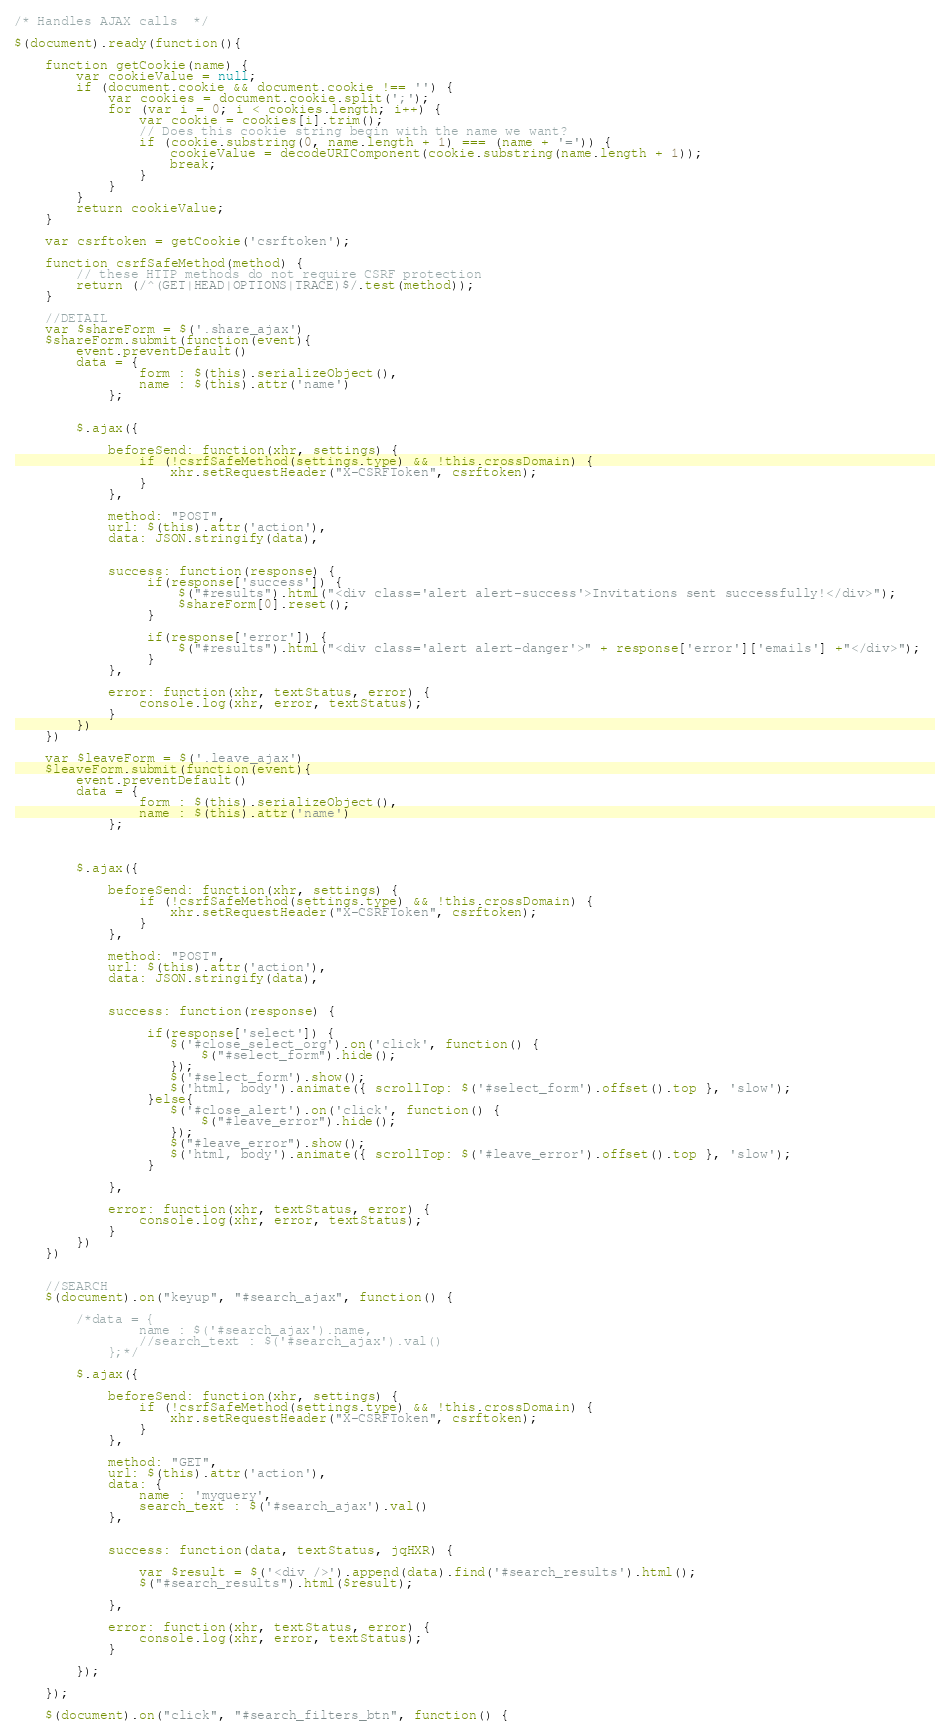<code> <loc_0><loc_0><loc_500><loc_500><_JavaScript_>/* Handles AJAX calls  */

$(document).ready(function(){

    function getCookie(name) {
        var cookieValue = null;
        if (document.cookie && document.cookie !== '') {
            var cookies = document.cookie.split(';');
            for (var i = 0; i < cookies.length; i++) {
                var cookie = cookies[i].trim();
                // Does this cookie string begin with the name we want?
                if (cookie.substring(0, name.length + 1) === (name + '=')) {
                    cookieValue = decodeURIComponent(cookie.substring(name.length + 1));
                    break;
                }
            }
        }
        return cookieValue;
    }

    var csrftoken = getCookie('csrftoken');

    function csrfSafeMethod(method) {
        // these HTTP methods do not require CSRF protection
        return (/^(GET|HEAD|OPTIONS|TRACE)$/.test(method));
    }

    //DETAIL
    var $shareForm = $('.share_ajax')
    $shareForm.submit(function(event){
        event.preventDefault()
        data = {
                form : $(this).serializeObject(),
                name : $(this).attr('name')
            };


        $.ajax({

            beforeSend: function(xhr, settings) {
                if (!csrfSafeMethod(settings.type) && !this.crossDomain) {
                    xhr.setRequestHeader("X-CSRFToken", csrftoken);
                }
            },

            method: "POST",
            url: $(this).attr('action'),
            data: JSON.stringify(data),


            success: function(response) {
                 if(response['success']) {
                     $("#results").html("<div class='alert alert-success'>Invitations sent successfully!</div>");
                     $shareForm[0].reset();
                 }

                 if(response['error']) {
                     $("#results").html("<div class='alert alert-danger'>" + response['error']['emails'] +"</div>");
                 }
            },

            error: function(xhr, textStatus, error) {
                console.log(xhr, error, textStatus);
            }
        })
    })

    var $leaveForm = $('.leave_ajax')
    $leaveForm.submit(function(event){
        event.preventDefault()
        data = {
                form : $(this).serializeObject(),
                name : $(this).attr('name')
            };

        

        $.ajax({

            beforeSend: function(xhr, settings) {
                if (!csrfSafeMethod(settings.type) && !this.crossDomain) {
                    xhr.setRequestHeader("X-CSRFToken", csrftoken);
                }
            },

            method: "POST",
            url: $(this).attr('action'),
            data: JSON.stringify(data),


            success: function(response) {

                 if(response['select']) {
                    $('#close_select_org').on('click', function() {
                        $("#select_form").hide();  
                    });
                    $('#select_form').show();
                    $('html, body').animate({ scrollTop: $('#select_form').offset().top }, 'slow');
                 }else{
                    $('#close_alert').on('click', function() {
                        $("#leave_error").hide();  
                    });
                    $("#leave_error").show();
                    $('html, body').animate({ scrollTop: $('#leave_error').offset().top }, 'slow');
                 }

            },

            error: function(xhr, textStatus, error) {
                console.log(xhr, error, textStatus);
            }
        })
    })

    
    //SEARCH
    $(document).on("keyup", "#search_ajax", function() {

        /*data = {
                name : $('#search_ajax').name,
                //search_text : $('#search_ajax').val()
            };*/

        $.ajax({

            beforeSend: function(xhr, settings) {
                if (!csrfSafeMethod(settings.type) && !this.crossDomain) {
                    xhr.setRequestHeader("X-CSRFToken", csrftoken);
                }
            },

            method: "GET",
            url: $(this).attr('action'),
            data: {
                name : 'myquery',
                search_text : $('#search_ajax').val()
            },


            success: function(data, textStatus, jqHXR) {

                var $result = $('<div />').append(data).find('#search_results').html();
                $("#search_results").html($result);

            },

            error: function(xhr, textStatus, error) {
                console.log(xhr, error, textStatus);
            }

        });

    });

    $(document).on("click", "#search_filters_btn", function() {
</code> 